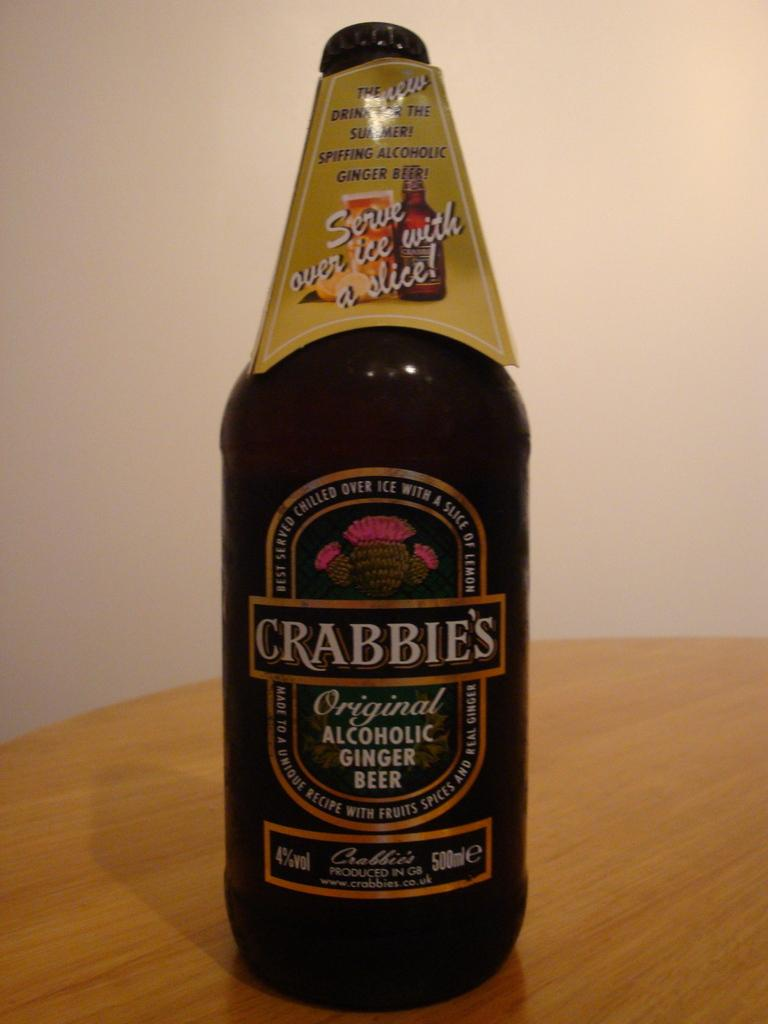What object can be seen in the image? There is a bottle in the image. What type of structure is visible in the image? There is a wall in the image. What type of gold lace can be seen on the wall in the image? There is no gold lace present on the wall in the image. 